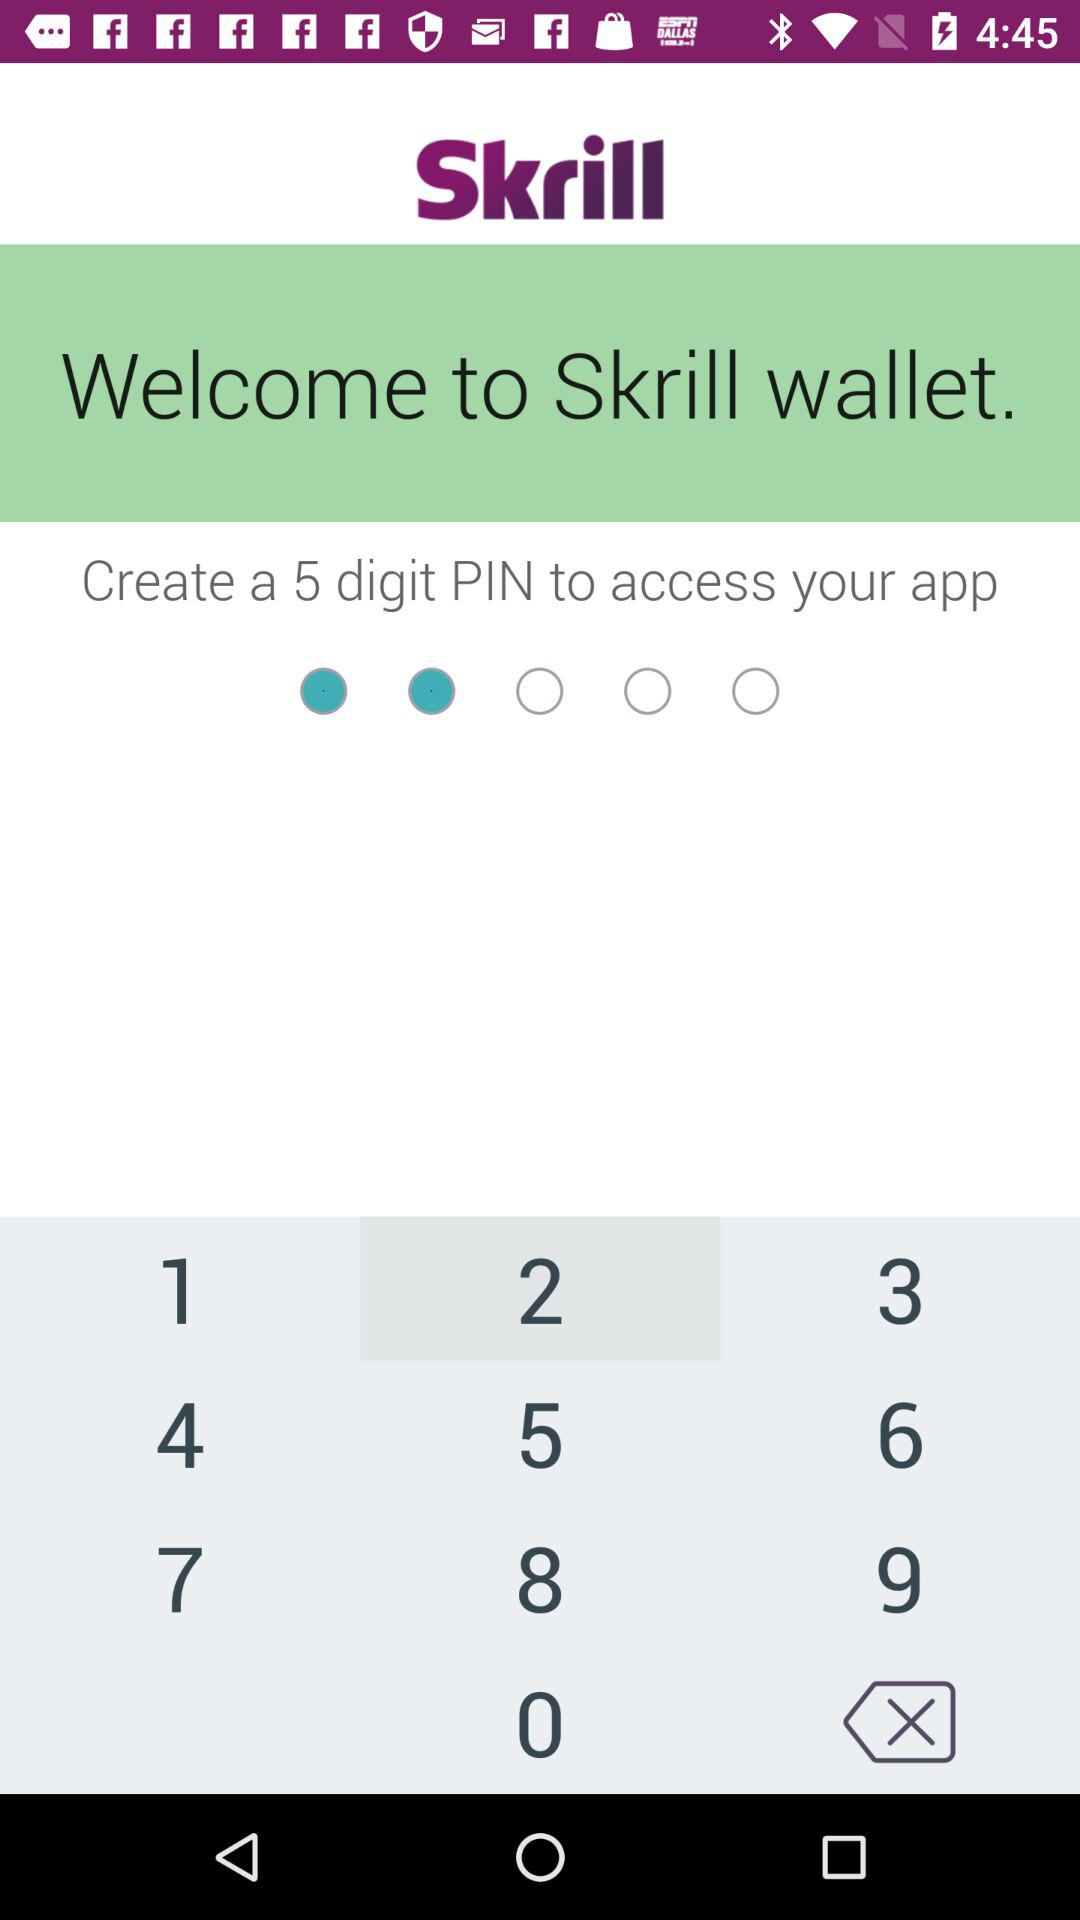How many digits PIN should be used to access the application? You should use a 5 digit PIN to access the application. 